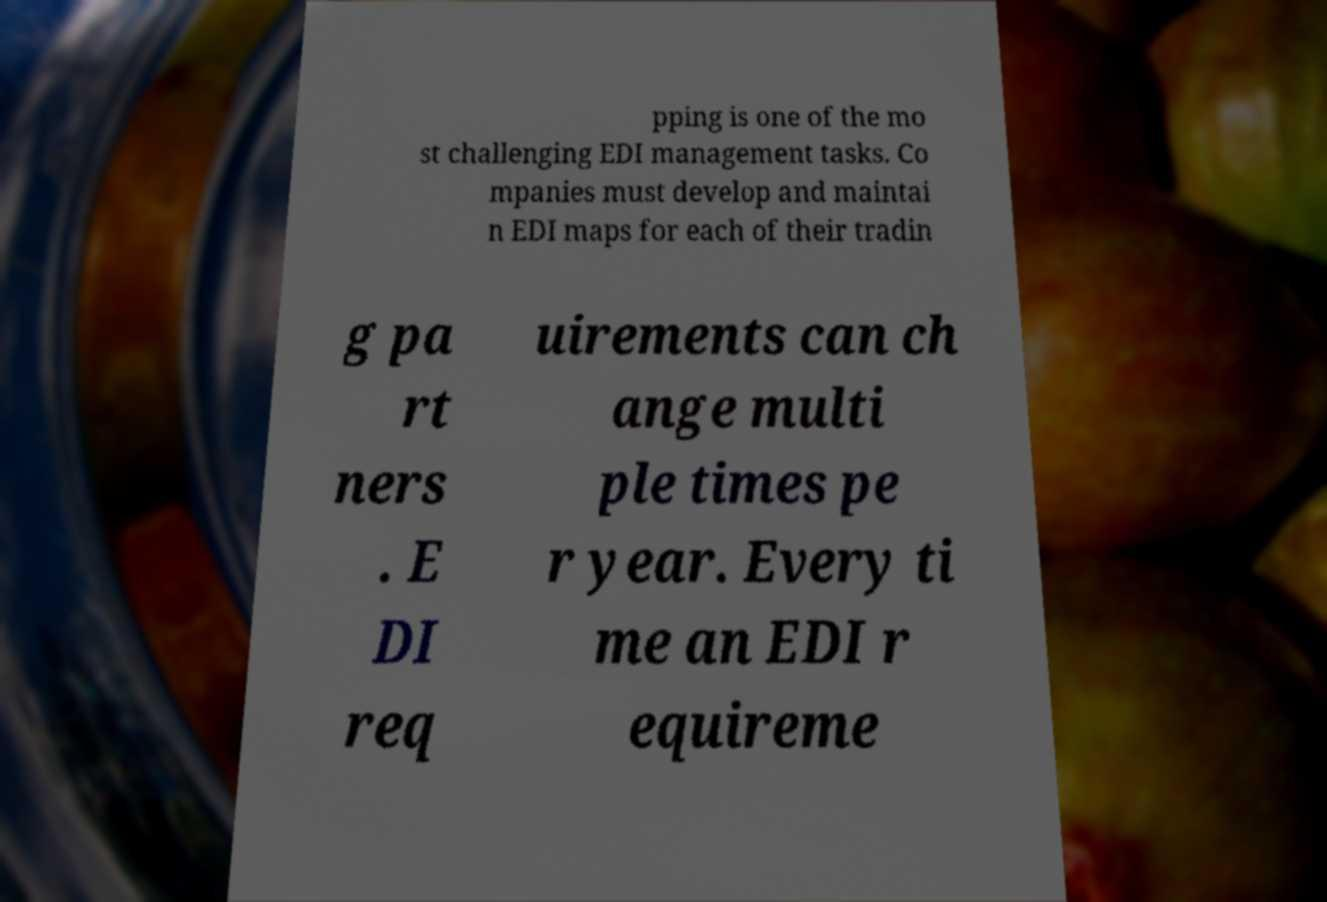Can you read and provide the text displayed in the image?This photo seems to have some interesting text. Can you extract and type it out for me? pping is one of the mo st challenging EDI management tasks. Co mpanies must develop and maintai n EDI maps for each of their tradin g pa rt ners . E DI req uirements can ch ange multi ple times pe r year. Every ti me an EDI r equireme 